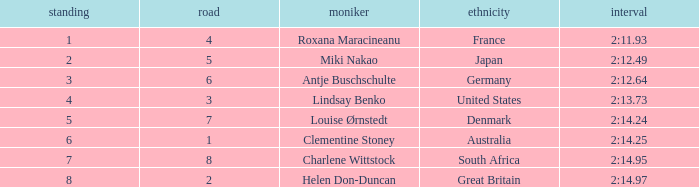What is the number of lane with a rank more than 2 for louise ørnstedt? 1.0. 